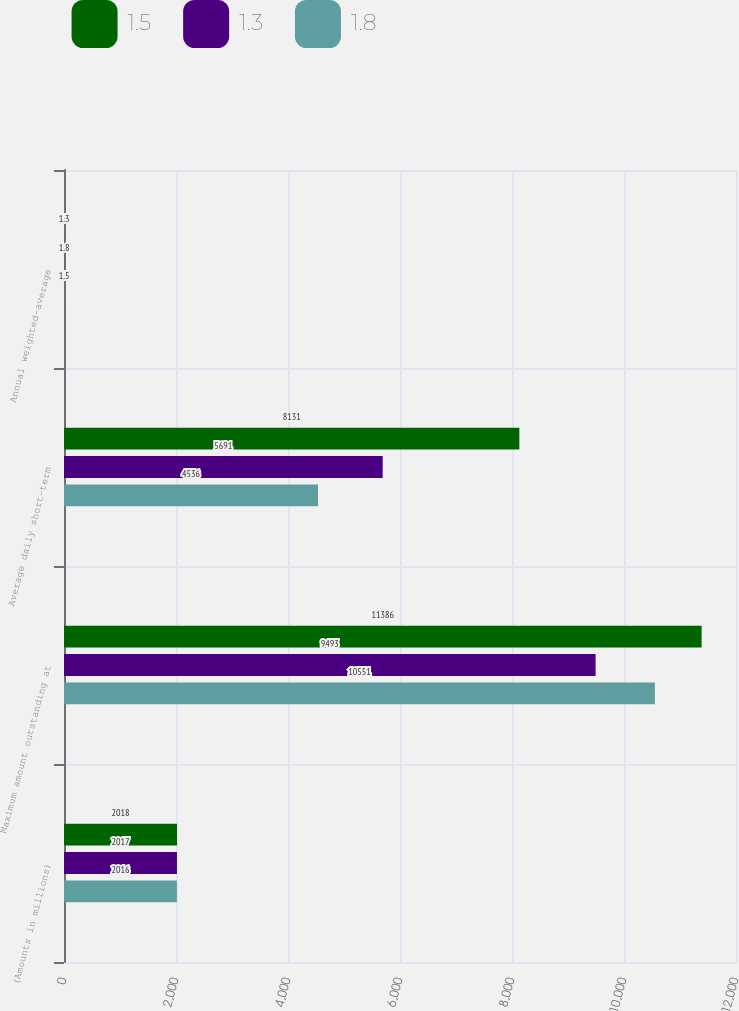<chart> <loc_0><loc_0><loc_500><loc_500><stacked_bar_chart><ecel><fcel>(Amounts in millions)<fcel>Maximum amount outstanding at<fcel>Average daily short-term<fcel>Annual weighted-average<nl><fcel>1.5<fcel>2018<fcel>11386<fcel>8131<fcel>1.3<nl><fcel>1.3<fcel>2017<fcel>9493<fcel>5691<fcel>1.8<nl><fcel>1.8<fcel>2016<fcel>10551<fcel>4536<fcel>1.5<nl></chart> 